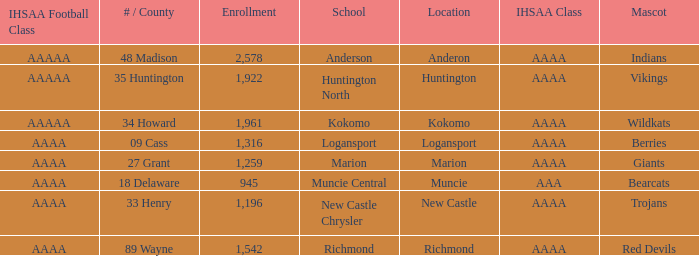What's the IHSAA class of the Red Devils? AAAA. 